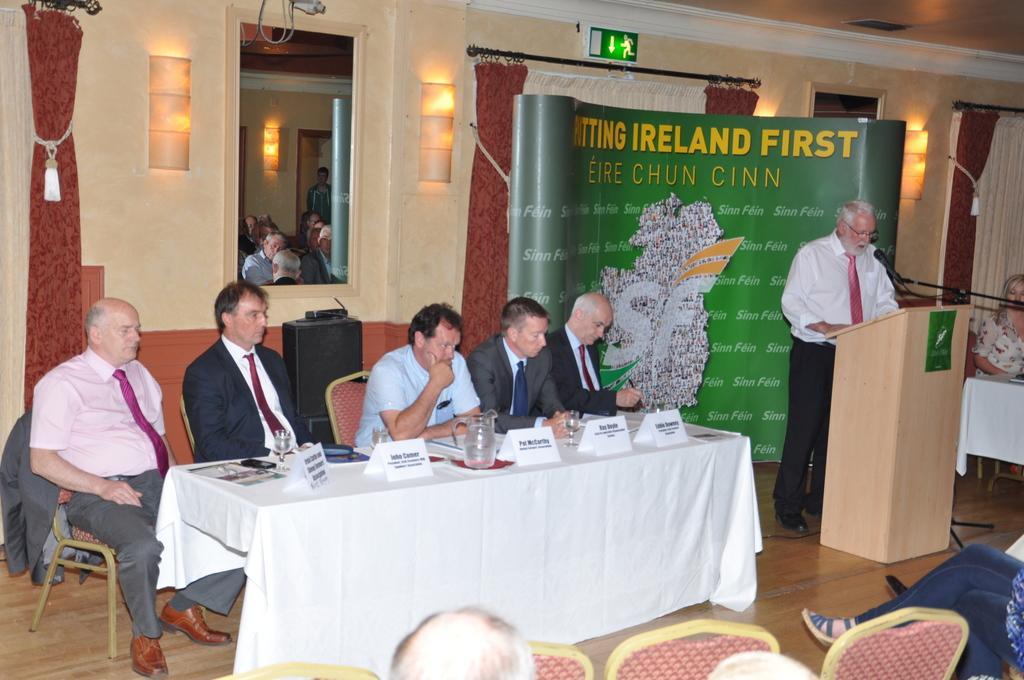In one or two sentences, can you explain what this image depicts? In this picture there are five people sitting on the chair in front of the desk on which there are some name plates and Jug and a person standing behind the wooden desk. 